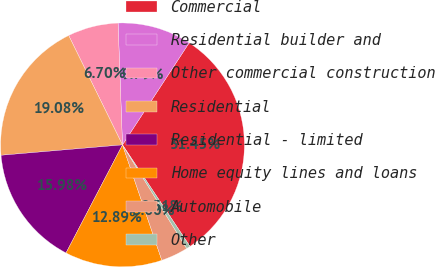Convert chart to OTSL. <chart><loc_0><loc_0><loc_500><loc_500><pie_chart><fcel>Commercial<fcel>Residential builder and<fcel>Other commercial construction<fcel>Residential<fcel>Residential - limited<fcel>Home equity lines and loans<fcel>Automobile<fcel>Other<nl><fcel>31.45%<fcel>9.79%<fcel>6.7%<fcel>19.08%<fcel>15.98%<fcel>12.89%<fcel>3.6%<fcel>0.51%<nl></chart> 